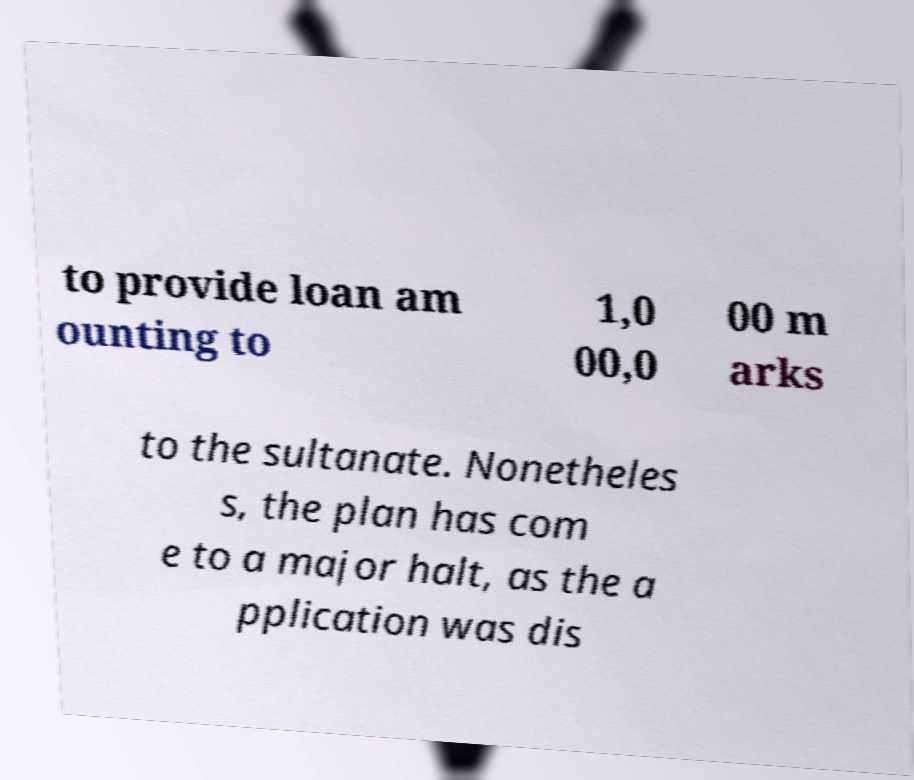I need the written content from this picture converted into text. Can you do that? to provide loan am ounting to 1,0 00,0 00 m arks to the sultanate. Nonetheles s, the plan has com e to a major halt, as the a pplication was dis 